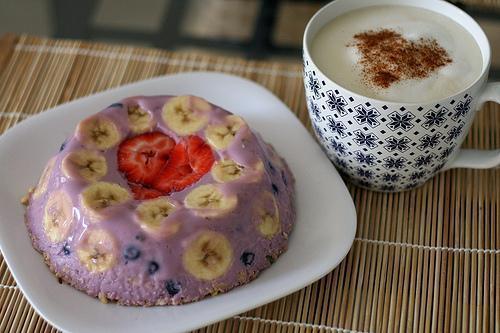How many cups are shown?
Give a very brief answer. 1. 